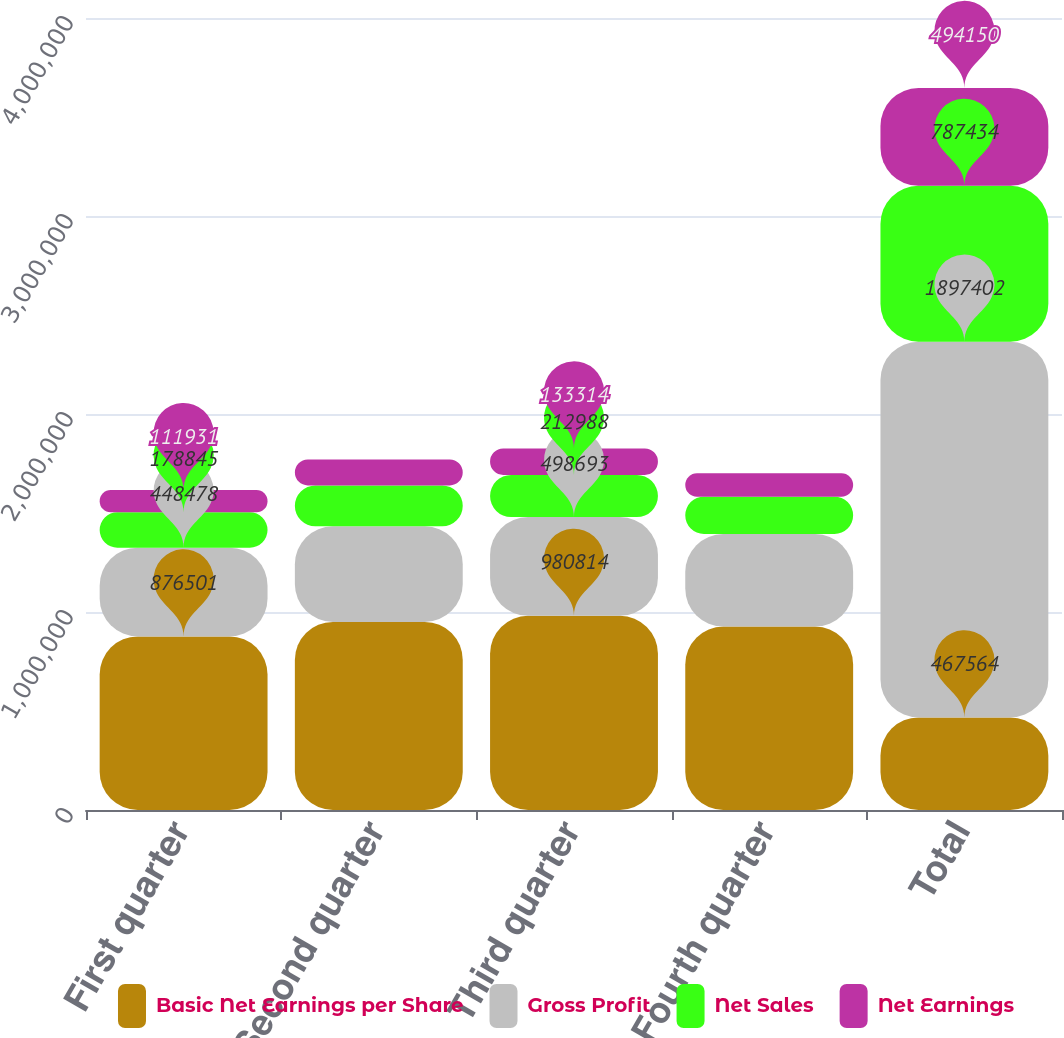<chart> <loc_0><loc_0><loc_500><loc_500><stacked_bar_chart><ecel><fcel>First quarter<fcel>Second quarter<fcel>Third quarter<fcel>Fourth quarter<fcel>Total<nl><fcel>Basic Net Earnings per Share<fcel>876501<fcel>949938<fcel>980814<fcel>926254<fcel>467564<nl><fcel>Gross Profit<fcel>448478<fcel>482667<fcel>498693<fcel>467564<fcel>1.8974e+06<nl><fcel>Net Sales<fcel>178845<fcel>206782<fcel>212988<fcel>188819<fcel>787434<nl><fcel>Net Earnings<fcel>111931<fcel>130514<fcel>133314<fcel>118391<fcel>494150<nl></chart> 